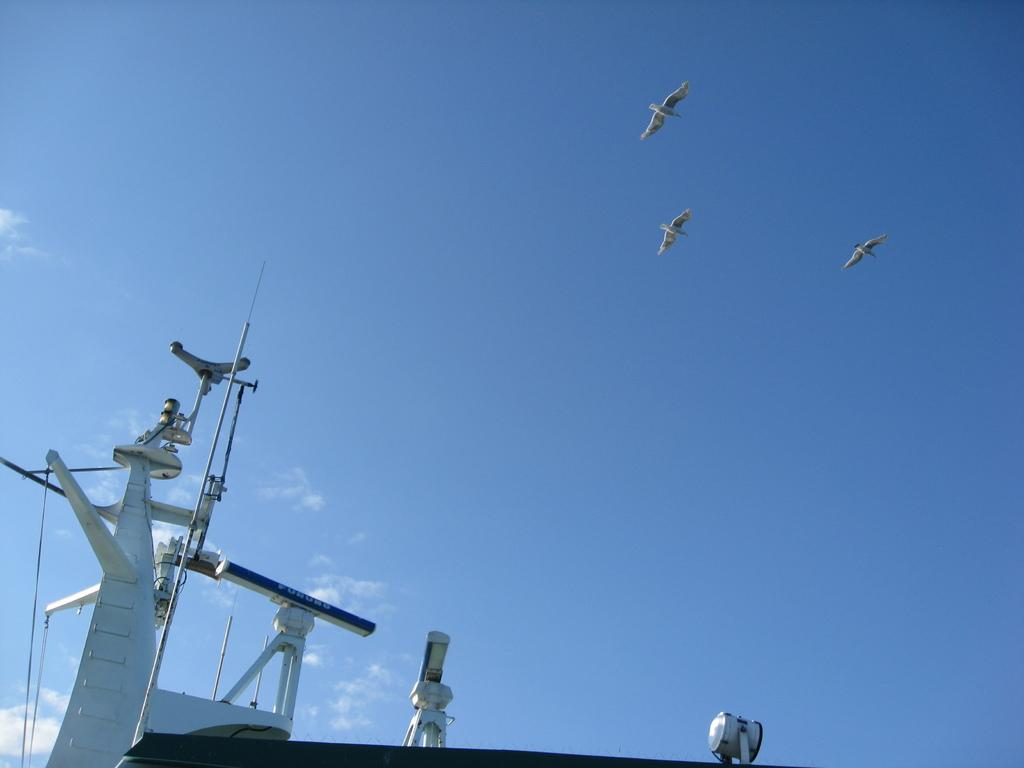Where was the image taken? The image was taken outdoors. What can be seen in the sky in the image? There is a sky with clouds in the image. What animals are flying in the sky in the image? Three birds are flying in the sky in the image. What type of vehicle is at the bottom of the image? There is a ship at the bottom of the image. What type of vest is being worn by the turkey in the image? There is no turkey or vest present in the image. 